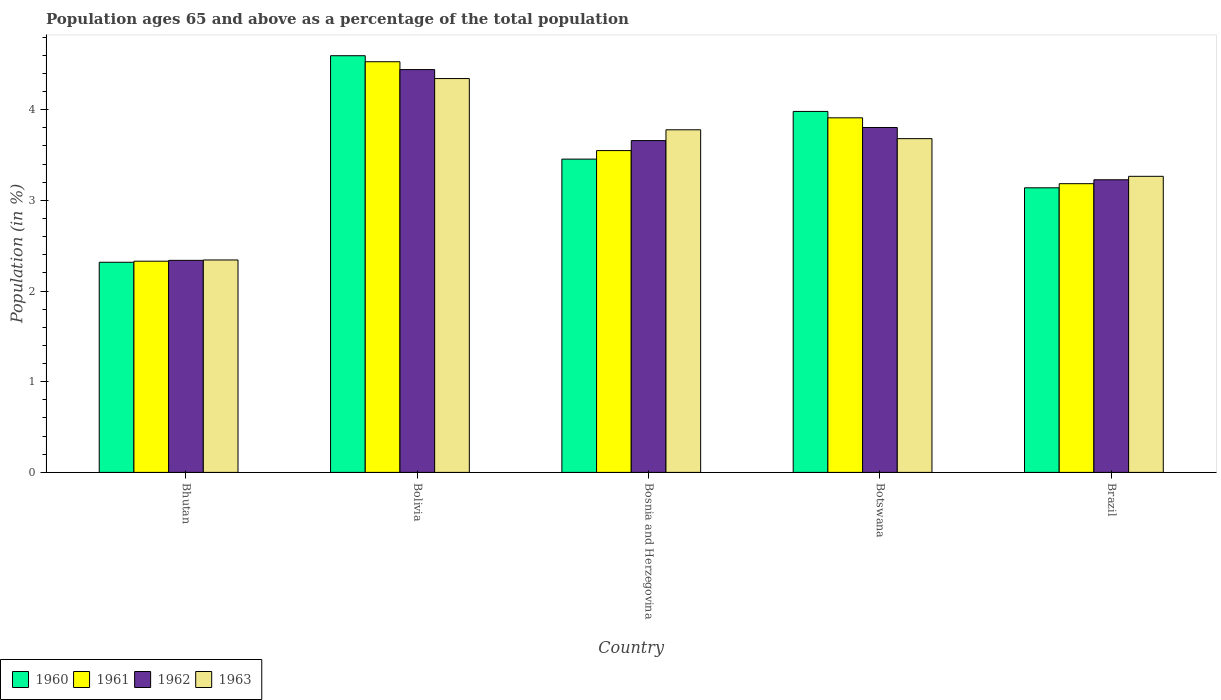How many groups of bars are there?
Your answer should be compact. 5. Are the number of bars per tick equal to the number of legend labels?
Provide a short and direct response. Yes. Are the number of bars on each tick of the X-axis equal?
Your answer should be very brief. Yes. How many bars are there on the 2nd tick from the left?
Give a very brief answer. 4. How many bars are there on the 1st tick from the right?
Your answer should be compact. 4. What is the label of the 5th group of bars from the left?
Your answer should be very brief. Brazil. What is the percentage of the population ages 65 and above in 1963 in Bosnia and Herzegovina?
Ensure brevity in your answer.  3.78. Across all countries, what is the maximum percentage of the population ages 65 and above in 1963?
Your response must be concise. 4.34. Across all countries, what is the minimum percentage of the population ages 65 and above in 1960?
Your answer should be compact. 2.32. In which country was the percentage of the population ages 65 and above in 1963 minimum?
Keep it short and to the point. Bhutan. What is the total percentage of the population ages 65 and above in 1961 in the graph?
Your response must be concise. 17.5. What is the difference between the percentage of the population ages 65 and above in 1960 in Bhutan and that in Bosnia and Herzegovina?
Provide a succinct answer. -1.14. What is the difference between the percentage of the population ages 65 and above in 1962 in Bolivia and the percentage of the population ages 65 and above in 1960 in Brazil?
Your answer should be very brief. 1.3. What is the average percentage of the population ages 65 and above in 1962 per country?
Your response must be concise. 3.49. What is the difference between the percentage of the population ages 65 and above of/in 1963 and percentage of the population ages 65 and above of/in 1962 in Botswana?
Offer a very short reply. -0.12. What is the ratio of the percentage of the population ages 65 and above in 1961 in Bolivia to that in Bosnia and Herzegovina?
Your response must be concise. 1.28. Is the percentage of the population ages 65 and above in 1963 in Bosnia and Herzegovina less than that in Brazil?
Provide a succinct answer. No. What is the difference between the highest and the second highest percentage of the population ages 65 and above in 1961?
Your answer should be very brief. -0.36. What is the difference between the highest and the lowest percentage of the population ages 65 and above in 1962?
Give a very brief answer. 2.1. In how many countries, is the percentage of the population ages 65 and above in 1962 greater than the average percentage of the population ages 65 and above in 1962 taken over all countries?
Your answer should be very brief. 3. Is the sum of the percentage of the population ages 65 and above in 1962 in Bhutan and Bolivia greater than the maximum percentage of the population ages 65 and above in 1961 across all countries?
Your answer should be compact. Yes. What does the 2nd bar from the left in Bosnia and Herzegovina represents?
Ensure brevity in your answer.  1961. What does the 4th bar from the right in Bhutan represents?
Your answer should be compact. 1960. How many bars are there?
Your answer should be very brief. 20. Are the values on the major ticks of Y-axis written in scientific E-notation?
Provide a succinct answer. No. Does the graph contain any zero values?
Give a very brief answer. No. Does the graph contain grids?
Your answer should be compact. No. Where does the legend appear in the graph?
Give a very brief answer. Bottom left. How many legend labels are there?
Offer a very short reply. 4. How are the legend labels stacked?
Your response must be concise. Horizontal. What is the title of the graph?
Your response must be concise. Population ages 65 and above as a percentage of the total population. Does "2006" appear as one of the legend labels in the graph?
Provide a succinct answer. No. What is the Population (in %) of 1960 in Bhutan?
Offer a very short reply. 2.32. What is the Population (in %) in 1961 in Bhutan?
Ensure brevity in your answer.  2.33. What is the Population (in %) of 1962 in Bhutan?
Provide a short and direct response. 2.34. What is the Population (in %) in 1963 in Bhutan?
Your answer should be compact. 2.34. What is the Population (in %) of 1960 in Bolivia?
Offer a very short reply. 4.6. What is the Population (in %) of 1961 in Bolivia?
Give a very brief answer. 4.53. What is the Population (in %) of 1962 in Bolivia?
Keep it short and to the point. 4.44. What is the Population (in %) of 1963 in Bolivia?
Your answer should be very brief. 4.34. What is the Population (in %) in 1960 in Bosnia and Herzegovina?
Offer a very short reply. 3.46. What is the Population (in %) in 1961 in Bosnia and Herzegovina?
Offer a very short reply. 3.55. What is the Population (in %) in 1962 in Bosnia and Herzegovina?
Keep it short and to the point. 3.66. What is the Population (in %) in 1963 in Bosnia and Herzegovina?
Provide a succinct answer. 3.78. What is the Population (in %) in 1960 in Botswana?
Provide a short and direct response. 3.98. What is the Population (in %) of 1961 in Botswana?
Provide a succinct answer. 3.91. What is the Population (in %) in 1962 in Botswana?
Provide a succinct answer. 3.8. What is the Population (in %) of 1963 in Botswana?
Offer a terse response. 3.68. What is the Population (in %) of 1960 in Brazil?
Your response must be concise. 3.14. What is the Population (in %) of 1961 in Brazil?
Your answer should be compact. 3.18. What is the Population (in %) of 1962 in Brazil?
Give a very brief answer. 3.23. What is the Population (in %) of 1963 in Brazil?
Give a very brief answer. 3.27. Across all countries, what is the maximum Population (in %) of 1960?
Ensure brevity in your answer.  4.6. Across all countries, what is the maximum Population (in %) in 1961?
Offer a terse response. 4.53. Across all countries, what is the maximum Population (in %) in 1962?
Your answer should be compact. 4.44. Across all countries, what is the maximum Population (in %) in 1963?
Offer a very short reply. 4.34. Across all countries, what is the minimum Population (in %) of 1960?
Give a very brief answer. 2.32. Across all countries, what is the minimum Population (in %) of 1961?
Give a very brief answer. 2.33. Across all countries, what is the minimum Population (in %) in 1962?
Make the answer very short. 2.34. Across all countries, what is the minimum Population (in %) in 1963?
Give a very brief answer. 2.34. What is the total Population (in %) of 1960 in the graph?
Keep it short and to the point. 17.49. What is the total Population (in %) in 1961 in the graph?
Give a very brief answer. 17.5. What is the total Population (in %) of 1962 in the graph?
Provide a succinct answer. 17.47. What is the total Population (in %) in 1963 in the graph?
Give a very brief answer. 17.41. What is the difference between the Population (in %) in 1960 in Bhutan and that in Bolivia?
Ensure brevity in your answer.  -2.28. What is the difference between the Population (in %) of 1961 in Bhutan and that in Bolivia?
Provide a succinct answer. -2.2. What is the difference between the Population (in %) of 1962 in Bhutan and that in Bolivia?
Provide a short and direct response. -2.1. What is the difference between the Population (in %) of 1963 in Bhutan and that in Bolivia?
Your answer should be compact. -2. What is the difference between the Population (in %) in 1960 in Bhutan and that in Bosnia and Herzegovina?
Offer a very short reply. -1.14. What is the difference between the Population (in %) of 1961 in Bhutan and that in Bosnia and Herzegovina?
Offer a terse response. -1.22. What is the difference between the Population (in %) of 1962 in Bhutan and that in Bosnia and Herzegovina?
Your answer should be compact. -1.32. What is the difference between the Population (in %) of 1963 in Bhutan and that in Bosnia and Herzegovina?
Provide a short and direct response. -1.44. What is the difference between the Population (in %) in 1960 in Bhutan and that in Botswana?
Offer a very short reply. -1.66. What is the difference between the Population (in %) of 1961 in Bhutan and that in Botswana?
Provide a short and direct response. -1.58. What is the difference between the Population (in %) in 1962 in Bhutan and that in Botswana?
Provide a short and direct response. -1.47. What is the difference between the Population (in %) in 1963 in Bhutan and that in Botswana?
Offer a terse response. -1.34. What is the difference between the Population (in %) of 1960 in Bhutan and that in Brazil?
Give a very brief answer. -0.82. What is the difference between the Population (in %) of 1961 in Bhutan and that in Brazil?
Offer a very short reply. -0.85. What is the difference between the Population (in %) of 1962 in Bhutan and that in Brazil?
Ensure brevity in your answer.  -0.89. What is the difference between the Population (in %) in 1963 in Bhutan and that in Brazil?
Give a very brief answer. -0.92. What is the difference between the Population (in %) of 1960 in Bolivia and that in Bosnia and Herzegovina?
Provide a succinct answer. 1.14. What is the difference between the Population (in %) of 1961 in Bolivia and that in Bosnia and Herzegovina?
Your answer should be compact. 0.98. What is the difference between the Population (in %) in 1962 in Bolivia and that in Bosnia and Herzegovina?
Keep it short and to the point. 0.78. What is the difference between the Population (in %) of 1963 in Bolivia and that in Bosnia and Herzegovina?
Your response must be concise. 0.56. What is the difference between the Population (in %) of 1960 in Bolivia and that in Botswana?
Ensure brevity in your answer.  0.61. What is the difference between the Population (in %) in 1961 in Bolivia and that in Botswana?
Keep it short and to the point. 0.62. What is the difference between the Population (in %) of 1962 in Bolivia and that in Botswana?
Provide a succinct answer. 0.64. What is the difference between the Population (in %) of 1963 in Bolivia and that in Botswana?
Provide a short and direct response. 0.66. What is the difference between the Population (in %) in 1960 in Bolivia and that in Brazil?
Keep it short and to the point. 1.46. What is the difference between the Population (in %) of 1961 in Bolivia and that in Brazil?
Your answer should be very brief. 1.34. What is the difference between the Population (in %) in 1962 in Bolivia and that in Brazil?
Provide a succinct answer. 1.22. What is the difference between the Population (in %) in 1963 in Bolivia and that in Brazil?
Your answer should be very brief. 1.08. What is the difference between the Population (in %) of 1960 in Bosnia and Herzegovina and that in Botswana?
Provide a short and direct response. -0.53. What is the difference between the Population (in %) in 1961 in Bosnia and Herzegovina and that in Botswana?
Make the answer very short. -0.36. What is the difference between the Population (in %) in 1962 in Bosnia and Herzegovina and that in Botswana?
Ensure brevity in your answer.  -0.14. What is the difference between the Population (in %) in 1963 in Bosnia and Herzegovina and that in Botswana?
Give a very brief answer. 0.1. What is the difference between the Population (in %) in 1960 in Bosnia and Herzegovina and that in Brazil?
Your answer should be very brief. 0.32. What is the difference between the Population (in %) of 1961 in Bosnia and Herzegovina and that in Brazil?
Make the answer very short. 0.37. What is the difference between the Population (in %) in 1962 in Bosnia and Herzegovina and that in Brazil?
Keep it short and to the point. 0.43. What is the difference between the Population (in %) of 1963 in Bosnia and Herzegovina and that in Brazil?
Make the answer very short. 0.51. What is the difference between the Population (in %) in 1960 in Botswana and that in Brazil?
Your answer should be compact. 0.84. What is the difference between the Population (in %) of 1961 in Botswana and that in Brazil?
Offer a very short reply. 0.73. What is the difference between the Population (in %) of 1962 in Botswana and that in Brazil?
Offer a terse response. 0.58. What is the difference between the Population (in %) in 1963 in Botswana and that in Brazil?
Provide a succinct answer. 0.42. What is the difference between the Population (in %) of 1960 in Bhutan and the Population (in %) of 1961 in Bolivia?
Keep it short and to the point. -2.21. What is the difference between the Population (in %) in 1960 in Bhutan and the Population (in %) in 1962 in Bolivia?
Provide a short and direct response. -2.12. What is the difference between the Population (in %) in 1960 in Bhutan and the Population (in %) in 1963 in Bolivia?
Your answer should be compact. -2.03. What is the difference between the Population (in %) of 1961 in Bhutan and the Population (in %) of 1962 in Bolivia?
Provide a succinct answer. -2.11. What is the difference between the Population (in %) in 1961 in Bhutan and the Population (in %) in 1963 in Bolivia?
Ensure brevity in your answer.  -2.01. What is the difference between the Population (in %) of 1962 in Bhutan and the Population (in %) of 1963 in Bolivia?
Provide a short and direct response. -2. What is the difference between the Population (in %) of 1960 in Bhutan and the Population (in %) of 1961 in Bosnia and Herzegovina?
Ensure brevity in your answer.  -1.23. What is the difference between the Population (in %) in 1960 in Bhutan and the Population (in %) in 1962 in Bosnia and Herzegovina?
Give a very brief answer. -1.34. What is the difference between the Population (in %) in 1960 in Bhutan and the Population (in %) in 1963 in Bosnia and Herzegovina?
Your answer should be very brief. -1.46. What is the difference between the Population (in %) of 1961 in Bhutan and the Population (in %) of 1962 in Bosnia and Herzegovina?
Make the answer very short. -1.33. What is the difference between the Population (in %) in 1961 in Bhutan and the Population (in %) in 1963 in Bosnia and Herzegovina?
Provide a succinct answer. -1.45. What is the difference between the Population (in %) of 1962 in Bhutan and the Population (in %) of 1963 in Bosnia and Herzegovina?
Provide a succinct answer. -1.44. What is the difference between the Population (in %) of 1960 in Bhutan and the Population (in %) of 1961 in Botswana?
Your answer should be very brief. -1.59. What is the difference between the Population (in %) in 1960 in Bhutan and the Population (in %) in 1962 in Botswana?
Your response must be concise. -1.49. What is the difference between the Population (in %) of 1960 in Bhutan and the Population (in %) of 1963 in Botswana?
Your response must be concise. -1.36. What is the difference between the Population (in %) of 1961 in Bhutan and the Population (in %) of 1962 in Botswana?
Make the answer very short. -1.47. What is the difference between the Population (in %) in 1961 in Bhutan and the Population (in %) in 1963 in Botswana?
Offer a terse response. -1.35. What is the difference between the Population (in %) in 1962 in Bhutan and the Population (in %) in 1963 in Botswana?
Ensure brevity in your answer.  -1.34. What is the difference between the Population (in %) in 1960 in Bhutan and the Population (in %) in 1961 in Brazil?
Your answer should be very brief. -0.87. What is the difference between the Population (in %) in 1960 in Bhutan and the Population (in %) in 1962 in Brazil?
Ensure brevity in your answer.  -0.91. What is the difference between the Population (in %) of 1960 in Bhutan and the Population (in %) of 1963 in Brazil?
Keep it short and to the point. -0.95. What is the difference between the Population (in %) of 1961 in Bhutan and the Population (in %) of 1962 in Brazil?
Provide a short and direct response. -0.9. What is the difference between the Population (in %) of 1961 in Bhutan and the Population (in %) of 1963 in Brazil?
Your answer should be compact. -0.94. What is the difference between the Population (in %) of 1962 in Bhutan and the Population (in %) of 1963 in Brazil?
Provide a succinct answer. -0.93. What is the difference between the Population (in %) of 1960 in Bolivia and the Population (in %) of 1961 in Bosnia and Herzegovina?
Make the answer very short. 1.05. What is the difference between the Population (in %) of 1960 in Bolivia and the Population (in %) of 1962 in Bosnia and Herzegovina?
Provide a succinct answer. 0.94. What is the difference between the Population (in %) of 1960 in Bolivia and the Population (in %) of 1963 in Bosnia and Herzegovina?
Give a very brief answer. 0.82. What is the difference between the Population (in %) of 1961 in Bolivia and the Population (in %) of 1962 in Bosnia and Herzegovina?
Ensure brevity in your answer.  0.87. What is the difference between the Population (in %) of 1961 in Bolivia and the Population (in %) of 1963 in Bosnia and Herzegovina?
Ensure brevity in your answer.  0.75. What is the difference between the Population (in %) in 1962 in Bolivia and the Population (in %) in 1963 in Bosnia and Herzegovina?
Provide a succinct answer. 0.66. What is the difference between the Population (in %) of 1960 in Bolivia and the Population (in %) of 1961 in Botswana?
Your answer should be compact. 0.69. What is the difference between the Population (in %) of 1960 in Bolivia and the Population (in %) of 1962 in Botswana?
Keep it short and to the point. 0.79. What is the difference between the Population (in %) in 1960 in Bolivia and the Population (in %) in 1963 in Botswana?
Give a very brief answer. 0.91. What is the difference between the Population (in %) in 1961 in Bolivia and the Population (in %) in 1962 in Botswana?
Your answer should be compact. 0.73. What is the difference between the Population (in %) in 1961 in Bolivia and the Population (in %) in 1963 in Botswana?
Your response must be concise. 0.85. What is the difference between the Population (in %) in 1962 in Bolivia and the Population (in %) in 1963 in Botswana?
Your answer should be very brief. 0.76. What is the difference between the Population (in %) in 1960 in Bolivia and the Population (in %) in 1961 in Brazil?
Your answer should be very brief. 1.41. What is the difference between the Population (in %) of 1960 in Bolivia and the Population (in %) of 1962 in Brazil?
Give a very brief answer. 1.37. What is the difference between the Population (in %) in 1960 in Bolivia and the Population (in %) in 1963 in Brazil?
Make the answer very short. 1.33. What is the difference between the Population (in %) of 1961 in Bolivia and the Population (in %) of 1962 in Brazil?
Your answer should be compact. 1.3. What is the difference between the Population (in %) in 1961 in Bolivia and the Population (in %) in 1963 in Brazil?
Ensure brevity in your answer.  1.26. What is the difference between the Population (in %) in 1962 in Bolivia and the Population (in %) in 1963 in Brazil?
Offer a terse response. 1.18. What is the difference between the Population (in %) of 1960 in Bosnia and Herzegovina and the Population (in %) of 1961 in Botswana?
Provide a short and direct response. -0.46. What is the difference between the Population (in %) in 1960 in Bosnia and Herzegovina and the Population (in %) in 1962 in Botswana?
Provide a short and direct response. -0.35. What is the difference between the Population (in %) of 1960 in Bosnia and Herzegovina and the Population (in %) of 1963 in Botswana?
Keep it short and to the point. -0.23. What is the difference between the Population (in %) of 1961 in Bosnia and Herzegovina and the Population (in %) of 1962 in Botswana?
Offer a terse response. -0.25. What is the difference between the Population (in %) of 1961 in Bosnia and Herzegovina and the Population (in %) of 1963 in Botswana?
Your answer should be compact. -0.13. What is the difference between the Population (in %) of 1962 in Bosnia and Herzegovina and the Population (in %) of 1963 in Botswana?
Your answer should be very brief. -0.02. What is the difference between the Population (in %) in 1960 in Bosnia and Herzegovina and the Population (in %) in 1961 in Brazil?
Make the answer very short. 0.27. What is the difference between the Population (in %) of 1960 in Bosnia and Herzegovina and the Population (in %) of 1962 in Brazil?
Provide a short and direct response. 0.23. What is the difference between the Population (in %) in 1960 in Bosnia and Herzegovina and the Population (in %) in 1963 in Brazil?
Give a very brief answer. 0.19. What is the difference between the Population (in %) in 1961 in Bosnia and Herzegovina and the Population (in %) in 1962 in Brazil?
Offer a terse response. 0.32. What is the difference between the Population (in %) of 1961 in Bosnia and Herzegovina and the Population (in %) of 1963 in Brazil?
Provide a succinct answer. 0.28. What is the difference between the Population (in %) of 1962 in Bosnia and Herzegovina and the Population (in %) of 1963 in Brazil?
Keep it short and to the point. 0.39. What is the difference between the Population (in %) of 1960 in Botswana and the Population (in %) of 1961 in Brazil?
Give a very brief answer. 0.8. What is the difference between the Population (in %) in 1960 in Botswana and the Population (in %) in 1962 in Brazil?
Provide a short and direct response. 0.75. What is the difference between the Population (in %) in 1960 in Botswana and the Population (in %) in 1963 in Brazil?
Provide a succinct answer. 0.72. What is the difference between the Population (in %) in 1961 in Botswana and the Population (in %) in 1962 in Brazil?
Ensure brevity in your answer.  0.68. What is the difference between the Population (in %) in 1961 in Botswana and the Population (in %) in 1963 in Brazil?
Keep it short and to the point. 0.65. What is the difference between the Population (in %) in 1962 in Botswana and the Population (in %) in 1963 in Brazil?
Your response must be concise. 0.54. What is the average Population (in %) in 1960 per country?
Provide a short and direct response. 3.5. What is the average Population (in %) in 1961 per country?
Offer a very short reply. 3.5. What is the average Population (in %) in 1962 per country?
Give a very brief answer. 3.49. What is the average Population (in %) in 1963 per country?
Provide a succinct answer. 3.48. What is the difference between the Population (in %) of 1960 and Population (in %) of 1961 in Bhutan?
Ensure brevity in your answer.  -0.01. What is the difference between the Population (in %) in 1960 and Population (in %) in 1962 in Bhutan?
Your response must be concise. -0.02. What is the difference between the Population (in %) of 1960 and Population (in %) of 1963 in Bhutan?
Make the answer very short. -0.03. What is the difference between the Population (in %) in 1961 and Population (in %) in 1962 in Bhutan?
Offer a terse response. -0.01. What is the difference between the Population (in %) of 1961 and Population (in %) of 1963 in Bhutan?
Keep it short and to the point. -0.01. What is the difference between the Population (in %) in 1962 and Population (in %) in 1963 in Bhutan?
Make the answer very short. -0. What is the difference between the Population (in %) of 1960 and Population (in %) of 1961 in Bolivia?
Provide a short and direct response. 0.07. What is the difference between the Population (in %) in 1960 and Population (in %) in 1962 in Bolivia?
Your answer should be very brief. 0.15. What is the difference between the Population (in %) in 1960 and Population (in %) in 1963 in Bolivia?
Provide a short and direct response. 0.25. What is the difference between the Population (in %) in 1961 and Population (in %) in 1962 in Bolivia?
Keep it short and to the point. 0.09. What is the difference between the Population (in %) in 1961 and Population (in %) in 1963 in Bolivia?
Your answer should be compact. 0.19. What is the difference between the Population (in %) of 1962 and Population (in %) of 1963 in Bolivia?
Give a very brief answer. 0.1. What is the difference between the Population (in %) of 1960 and Population (in %) of 1961 in Bosnia and Herzegovina?
Give a very brief answer. -0.09. What is the difference between the Population (in %) of 1960 and Population (in %) of 1962 in Bosnia and Herzegovina?
Provide a short and direct response. -0.2. What is the difference between the Population (in %) in 1960 and Population (in %) in 1963 in Bosnia and Herzegovina?
Offer a very short reply. -0.32. What is the difference between the Population (in %) in 1961 and Population (in %) in 1962 in Bosnia and Herzegovina?
Make the answer very short. -0.11. What is the difference between the Population (in %) of 1961 and Population (in %) of 1963 in Bosnia and Herzegovina?
Your answer should be very brief. -0.23. What is the difference between the Population (in %) in 1962 and Population (in %) in 1963 in Bosnia and Herzegovina?
Make the answer very short. -0.12. What is the difference between the Population (in %) in 1960 and Population (in %) in 1961 in Botswana?
Offer a terse response. 0.07. What is the difference between the Population (in %) of 1960 and Population (in %) of 1962 in Botswana?
Your response must be concise. 0.18. What is the difference between the Population (in %) of 1960 and Population (in %) of 1963 in Botswana?
Provide a short and direct response. 0.3. What is the difference between the Population (in %) of 1961 and Population (in %) of 1962 in Botswana?
Make the answer very short. 0.11. What is the difference between the Population (in %) of 1961 and Population (in %) of 1963 in Botswana?
Your answer should be compact. 0.23. What is the difference between the Population (in %) of 1962 and Population (in %) of 1963 in Botswana?
Offer a very short reply. 0.12. What is the difference between the Population (in %) in 1960 and Population (in %) in 1961 in Brazil?
Your response must be concise. -0.05. What is the difference between the Population (in %) of 1960 and Population (in %) of 1962 in Brazil?
Make the answer very short. -0.09. What is the difference between the Population (in %) in 1960 and Population (in %) in 1963 in Brazil?
Offer a terse response. -0.13. What is the difference between the Population (in %) in 1961 and Population (in %) in 1962 in Brazil?
Your answer should be compact. -0.04. What is the difference between the Population (in %) in 1961 and Population (in %) in 1963 in Brazil?
Offer a terse response. -0.08. What is the difference between the Population (in %) of 1962 and Population (in %) of 1963 in Brazil?
Offer a very short reply. -0.04. What is the ratio of the Population (in %) in 1960 in Bhutan to that in Bolivia?
Your answer should be very brief. 0.5. What is the ratio of the Population (in %) in 1961 in Bhutan to that in Bolivia?
Offer a terse response. 0.51. What is the ratio of the Population (in %) in 1962 in Bhutan to that in Bolivia?
Give a very brief answer. 0.53. What is the ratio of the Population (in %) of 1963 in Bhutan to that in Bolivia?
Your answer should be very brief. 0.54. What is the ratio of the Population (in %) of 1960 in Bhutan to that in Bosnia and Herzegovina?
Provide a succinct answer. 0.67. What is the ratio of the Population (in %) in 1961 in Bhutan to that in Bosnia and Herzegovina?
Ensure brevity in your answer.  0.66. What is the ratio of the Population (in %) of 1962 in Bhutan to that in Bosnia and Herzegovina?
Give a very brief answer. 0.64. What is the ratio of the Population (in %) in 1963 in Bhutan to that in Bosnia and Herzegovina?
Give a very brief answer. 0.62. What is the ratio of the Population (in %) of 1960 in Bhutan to that in Botswana?
Your response must be concise. 0.58. What is the ratio of the Population (in %) in 1961 in Bhutan to that in Botswana?
Keep it short and to the point. 0.6. What is the ratio of the Population (in %) of 1962 in Bhutan to that in Botswana?
Provide a short and direct response. 0.61. What is the ratio of the Population (in %) of 1963 in Bhutan to that in Botswana?
Give a very brief answer. 0.64. What is the ratio of the Population (in %) in 1960 in Bhutan to that in Brazil?
Keep it short and to the point. 0.74. What is the ratio of the Population (in %) in 1961 in Bhutan to that in Brazil?
Keep it short and to the point. 0.73. What is the ratio of the Population (in %) of 1962 in Bhutan to that in Brazil?
Offer a very short reply. 0.72. What is the ratio of the Population (in %) of 1963 in Bhutan to that in Brazil?
Make the answer very short. 0.72. What is the ratio of the Population (in %) in 1960 in Bolivia to that in Bosnia and Herzegovina?
Your answer should be compact. 1.33. What is the ratio of the Population (in %) in 1961 in Bolivia to that in Bosnia and Herzegovina?
Ensure brevity in your answer.  1.28. What is the ratio of the Population (in %) of 1962 in Bolivia to that in Bosnia and Herzegovina?
Keep it short and to the point. 1.21. What is the ratio of the Population (in %) of 1963 in Bolivia to that in Bosnia and Herzegovina?
Ensure brevity in your answer.  1.15. What is the ratio of the Population (in %) in 1960 in Bolivia to that in Botswana?
Your answer should be compact. 1.15. What is the ratio of the Population (in %) in 1961 in Bolivia to that in Botswana?
Offer a very short reply. 1.16. What is the ratio of the Population (in %) in 1962 in Bolivia to that in Botswana?
Provide a short and direct response. 1.17. What is the ratio of the Population (in %) of 1963 in Bolivia to that in Botswana?
Ensure brevity in your answer.  1.18. What is the ratio of the Population (in %) in 1960 in Bolivia to that in Brazil?
Offer a very short reply. 1.46. What is the ratio of the Population (in %) of 1961 in Bolivia to that in Brazil?
Make the answer very short. 1.42. What is the ratio of the Population (in %) in 1962 in Bolivia to that in Brazil?
Provide a succinct answer. 1.38. What is the ratio of the Population (in %) of 1963 in Bolivia to that in Brazil?
Offer a very short reply. 1.33. What is the ratio of the Population (in %) of 1960 in Bosnia and Herzegovina to that in Botswana?
Provide a short and direct response. 0.87. What is the ratio of the Population (in %) of 1961 in Bosnia and Herzegovina to that in Botswana?
Your answer should be compact. 0.91. What is the ratio of the Population (in %) of 1962 in Bosnia and Herzegovina to that in Botswana?
Offer a very short reply. 0.96. What is the ratio of the Population (in %) in 1963 in Bosnia and Herzegovina to that in Botswana?
Provide a succinct answer. 1.03. What is the ratio of the Population (in %) of 1960 in Bosnia and Herzegovina to that in Brazil?
Your answer should be very brief. 1.1. What is the ratio of the Population (in %) in 1961 in Bosnia and Herzegovina to that in Brazil?
Provide a short and direct response. 1.11. What is the ratio of the Population (in %) in 1962 in Bosnia and Herzegovina to that in Brazil?
Offer a very short reply. 1.13. What is the ratio of the Population (in %) in 1963 in Bosnia and Herzegovina to that in Brazil?
Offer a very short reply. 1.16. What is the ratio of the Population (in %) of 1960 in Botswana to that in Brazil?
Offer a very short reply. 1.27. What is the ratio of the Population (in %) in 1961 in Botswana to that in Brazil?
Your answer should be very brief. 1.23. What is the ratio of the Population (in %) of 1962 in Botswana to that in Brazil?
Your answer should be very brief. 1.18. What is the ratio of the Population (in %) in 1963 in Botswana to that in Brazil?
Provide a succinct answer. 1.13. What is the difference between the highest and the second highest Population (in %) of 1960?
Ensure brevity in your answer.  0.61. What is the difference between the highest and the second highest Population (in %) of 1961?
Provide a short and direct response. 0.62. What is the difference between the highest and the second highest Population (in %) in 1962?
Provide a short and direct response. 0.64. What is the difference between the highest and the second highest Population (in %) of 1963?
Keep it short and to the point. 0.56. What is the difference between the highest and the lowest Population (in %) in 1960?
Offer a very short reply. 2.28. What is the difference between the highest and the lowest Population (in %) in 1961?
Offer a very short reply. 2.2. What is the difference between the highest and the lowest Population (in %) of 1962?
Your answer should be very brief. 2.1. What is the difference between the highest and the lowest Population (in %) in 1963?
Provide a short and direct response. 2. 